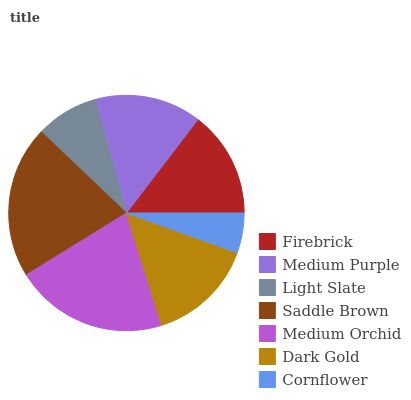Is Cornflower the minimum?
Answer yes or no. Yes. Is Medium Orchid the maximum?
Answer yes or no. Yes. Is Medium Purple the minimum?
Answer yes or no. No. Is Medium Purple the maximum?
Answer yes or no. No. Is Medium Purple greater than Firebrick?
Answer yes or no. Yes. Is Firebrick less than Medium Purple?
Answer yes or no. Yes. Is Firebrick greater than Medium Purple?
Answer yes or no. No. Is Medium Purple less than Firebrick?
Answer yes or no. No. Is Medium Purple the high median?
Answer yes or no. Yes. Is Medium Purple the low median?
Answer yes or no. Yes. Is Light Slate the high median?
Answer yes or no. No. Is Saddle Brown the low median?
Answer yes or no. No. 